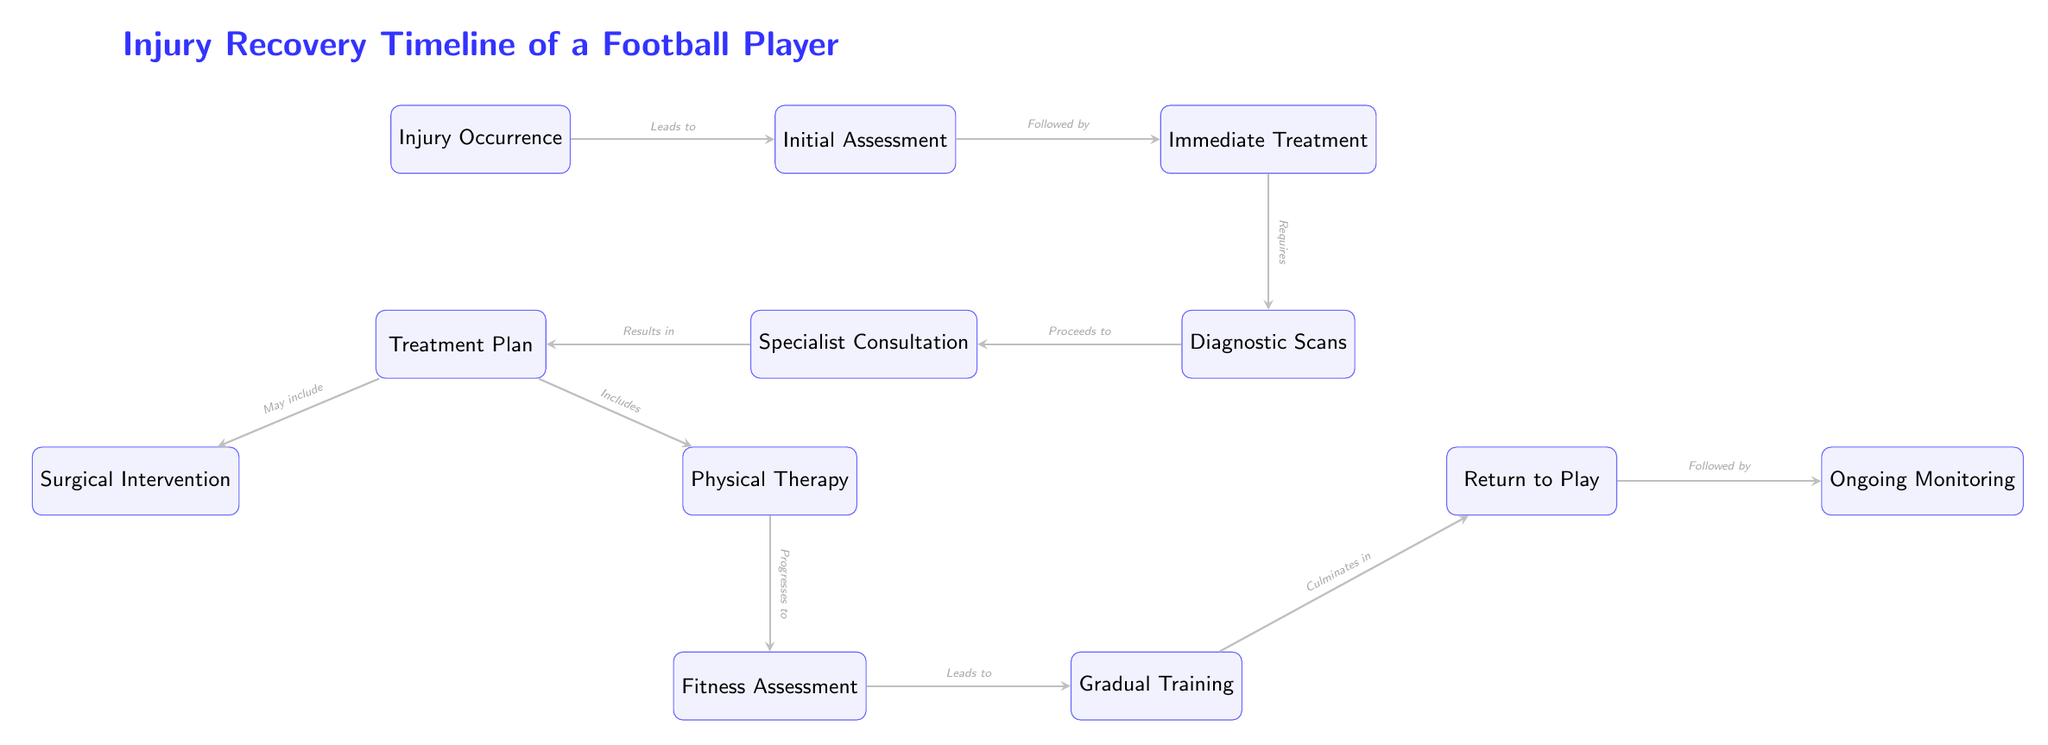What's the first step in the injury recovery timeline? The diagram starts with the node labeled "Injury Occurrence," which indicates the initial event that triggers the recovery process.
Answer: Injury Occurrence How many main steps are in the injury recovery process? By counting the nodes from "Initial Assessment" to "Ongoing Monitoring," there are a total of 10 main steps, including all treatment and assessment phases.
Answer: 10 Which node follows the "Diagnostic Scans"? The flow from "Diagnostic Scans" leads directly to the "Specialist Consultation," making it the next step in the recovery timeline.
Answer: Specialist Consultation What treatment options are included in the "Treatment Plan"? The "Treatment Plan" node leads to two options: "Surgical Intervention" and "Physical Therapy," illustrating the different paths for recovery.
Answer: Surgical Intervention, Physical Therapy How does "Fitness Assessment" relate to "Gradual Training"? The arrow from "Fitness Assessment" to "Gradual Training" indicates that a fitness assessment is completed before starting gradual training, showing a logical progression in the recovery.
Answer: Leads to What is the last stage in the recovery timeline? The final node, "Ongoing Monitoring," represents the stage that follows the return to play, ensuring continuous observation after the player resumes activities.
Answer: Ongoing Monitoring Which nodes show a bifurcation from "Treatment Plan"? From the "Treatment Plan" node, there are two branches leading to "Surgical Intervention" and "Physical Therapy," indicating the possibility of multiple treatment paths.
Answer: Surgical Intervention, Physical Therapy What action follows "Return to Play"? After the player returns to play, the next action is "Ongoing Monitoring," which includes continued assessment to ensure the player's fitness and safety.
Answer: Ongoing Monitoring 